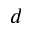Convert formula to latex. <formula><loc_0><loc_0><loc_500><loc_500>d</formula> 